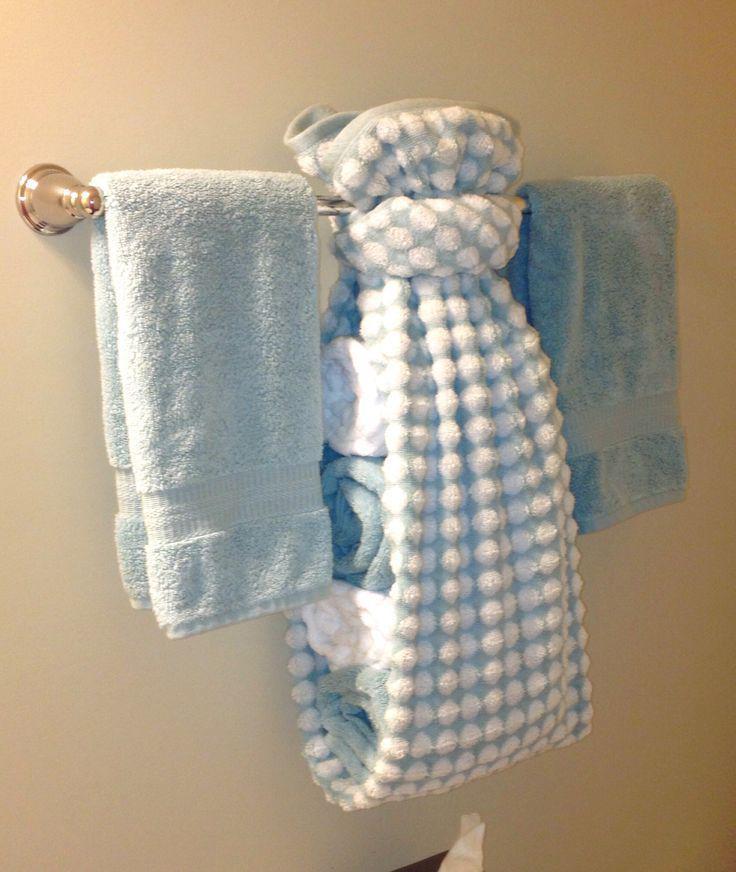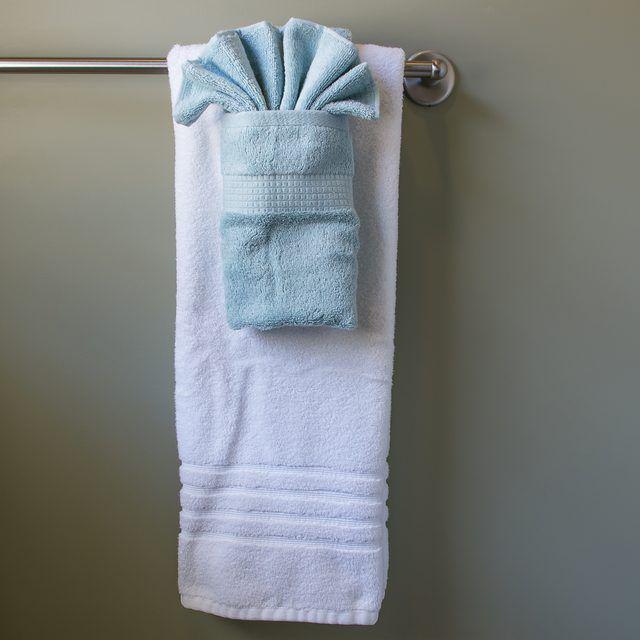The first image is the image on the left, the second image is the image on the right. Examine the images to the left and right. Is the description "There are blue towels." accurate? Answer yes or no. Yes. The first image is the image on the left, the second image is the image on the right. Assess this claim about the two images: "One of the blue towels is folded into a fan shape on the top part.". Correct or not? Answer yes or no. Yes. 